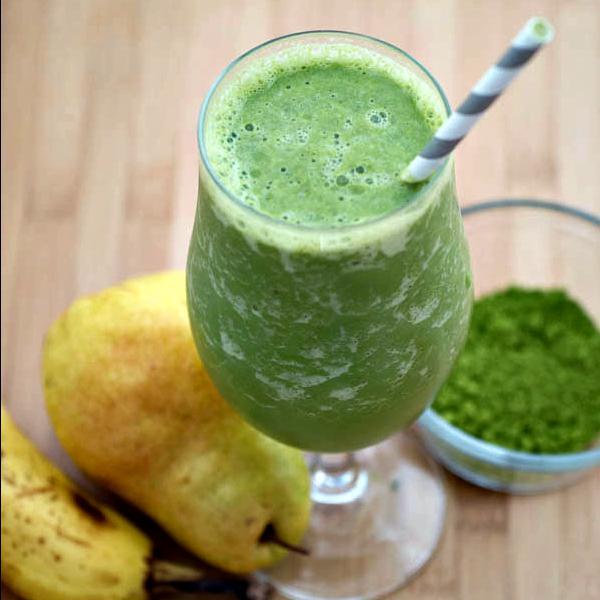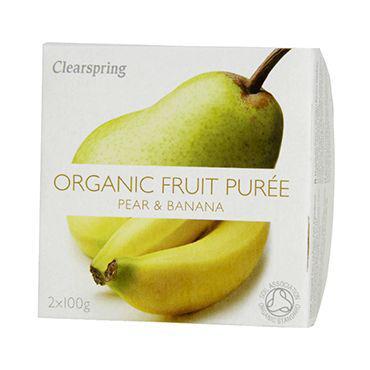The first image is the image on the left, the second image is the image on the right. Given the left and right images, does the statement "An image shows exactly one creamy green drink served in a footed glass." hold true? Answer yes or no. Yes. The first image is the image on the left, the second image is the image on the right. For the images shown, is this caption "The image on the left has at least one striped straw." true? Answer yes or no. Yes. 